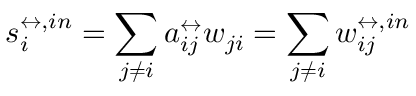<formula> <loc_0><loc_0><loc_500><loc_500>s _ { i } ^ { \leftrightarrow , i n } = \sum _ { j \neq i } a _ { i j } ^ { \leftrightarrow } w _ { j i } = \sum _ { j \neq i } w _ { i j } ^ { \leftrightarrow , i n }</formula> 